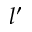<formula> <loc_0><loc_0><loc_500><loc_500>l ^ { \prime }</formula> 